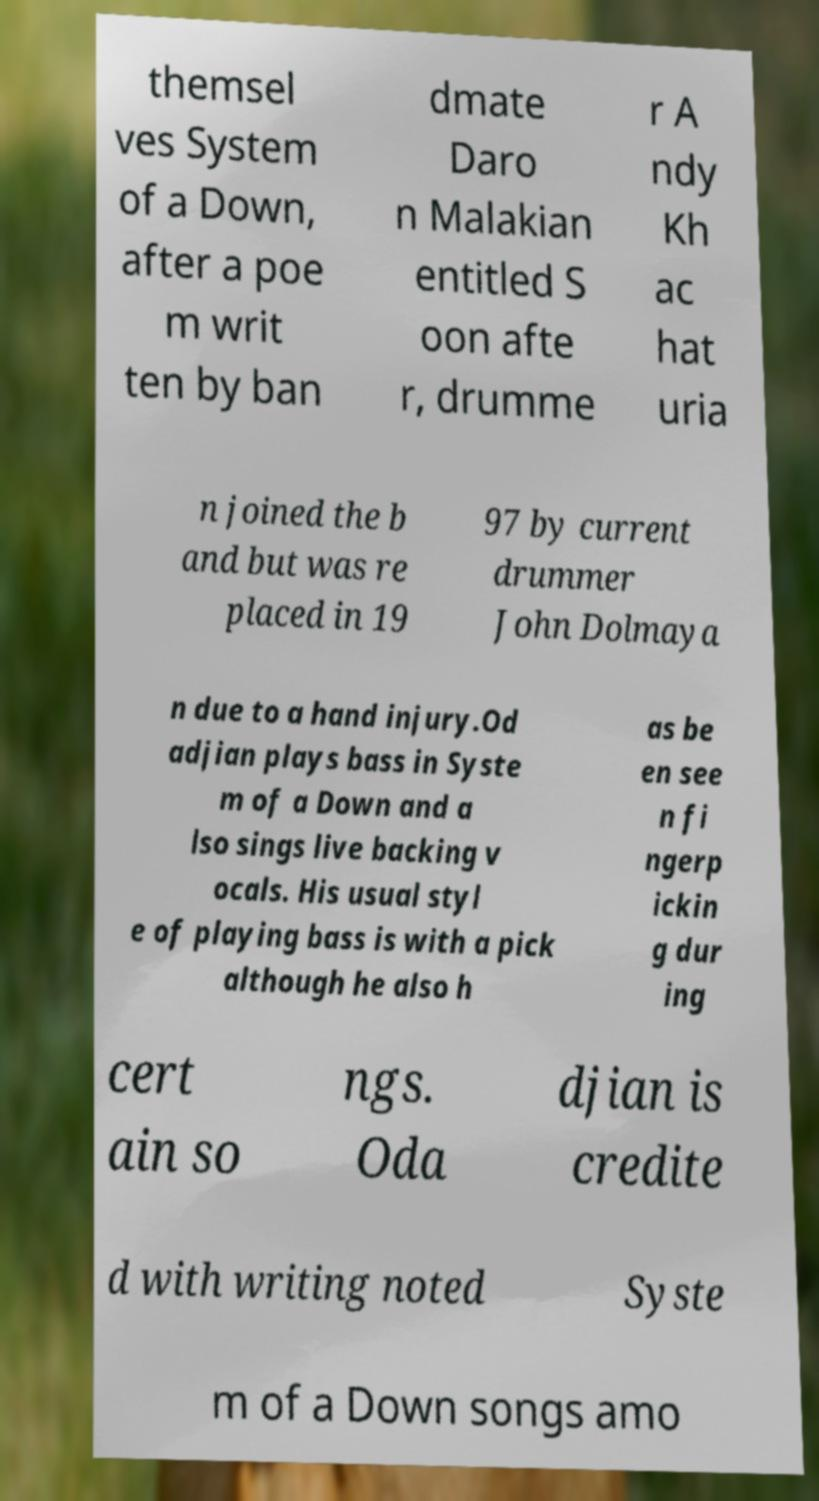There's text embedded in this image that I need extracted. Can you transcribe it verbatim? themsel ves System of a Down, after a poe m writ ten by ban dmate Daro n Malakian entitled S oon afte r, drumme r A ndy Kh ac hat uria n joined the b and but was re placed in 19 97 by current drummer John Dolmaya n due to a hand injury.Od adjian plays bass in Syste m of a Down and a lso sings live backing v ocals. His usual styl e of playing bass is with a pick although he also h as be en see n fi ngerp ickin g dur ing cert ain so ngs. Oda djian is credite d with writing noted Syste m of a Down songs amo 